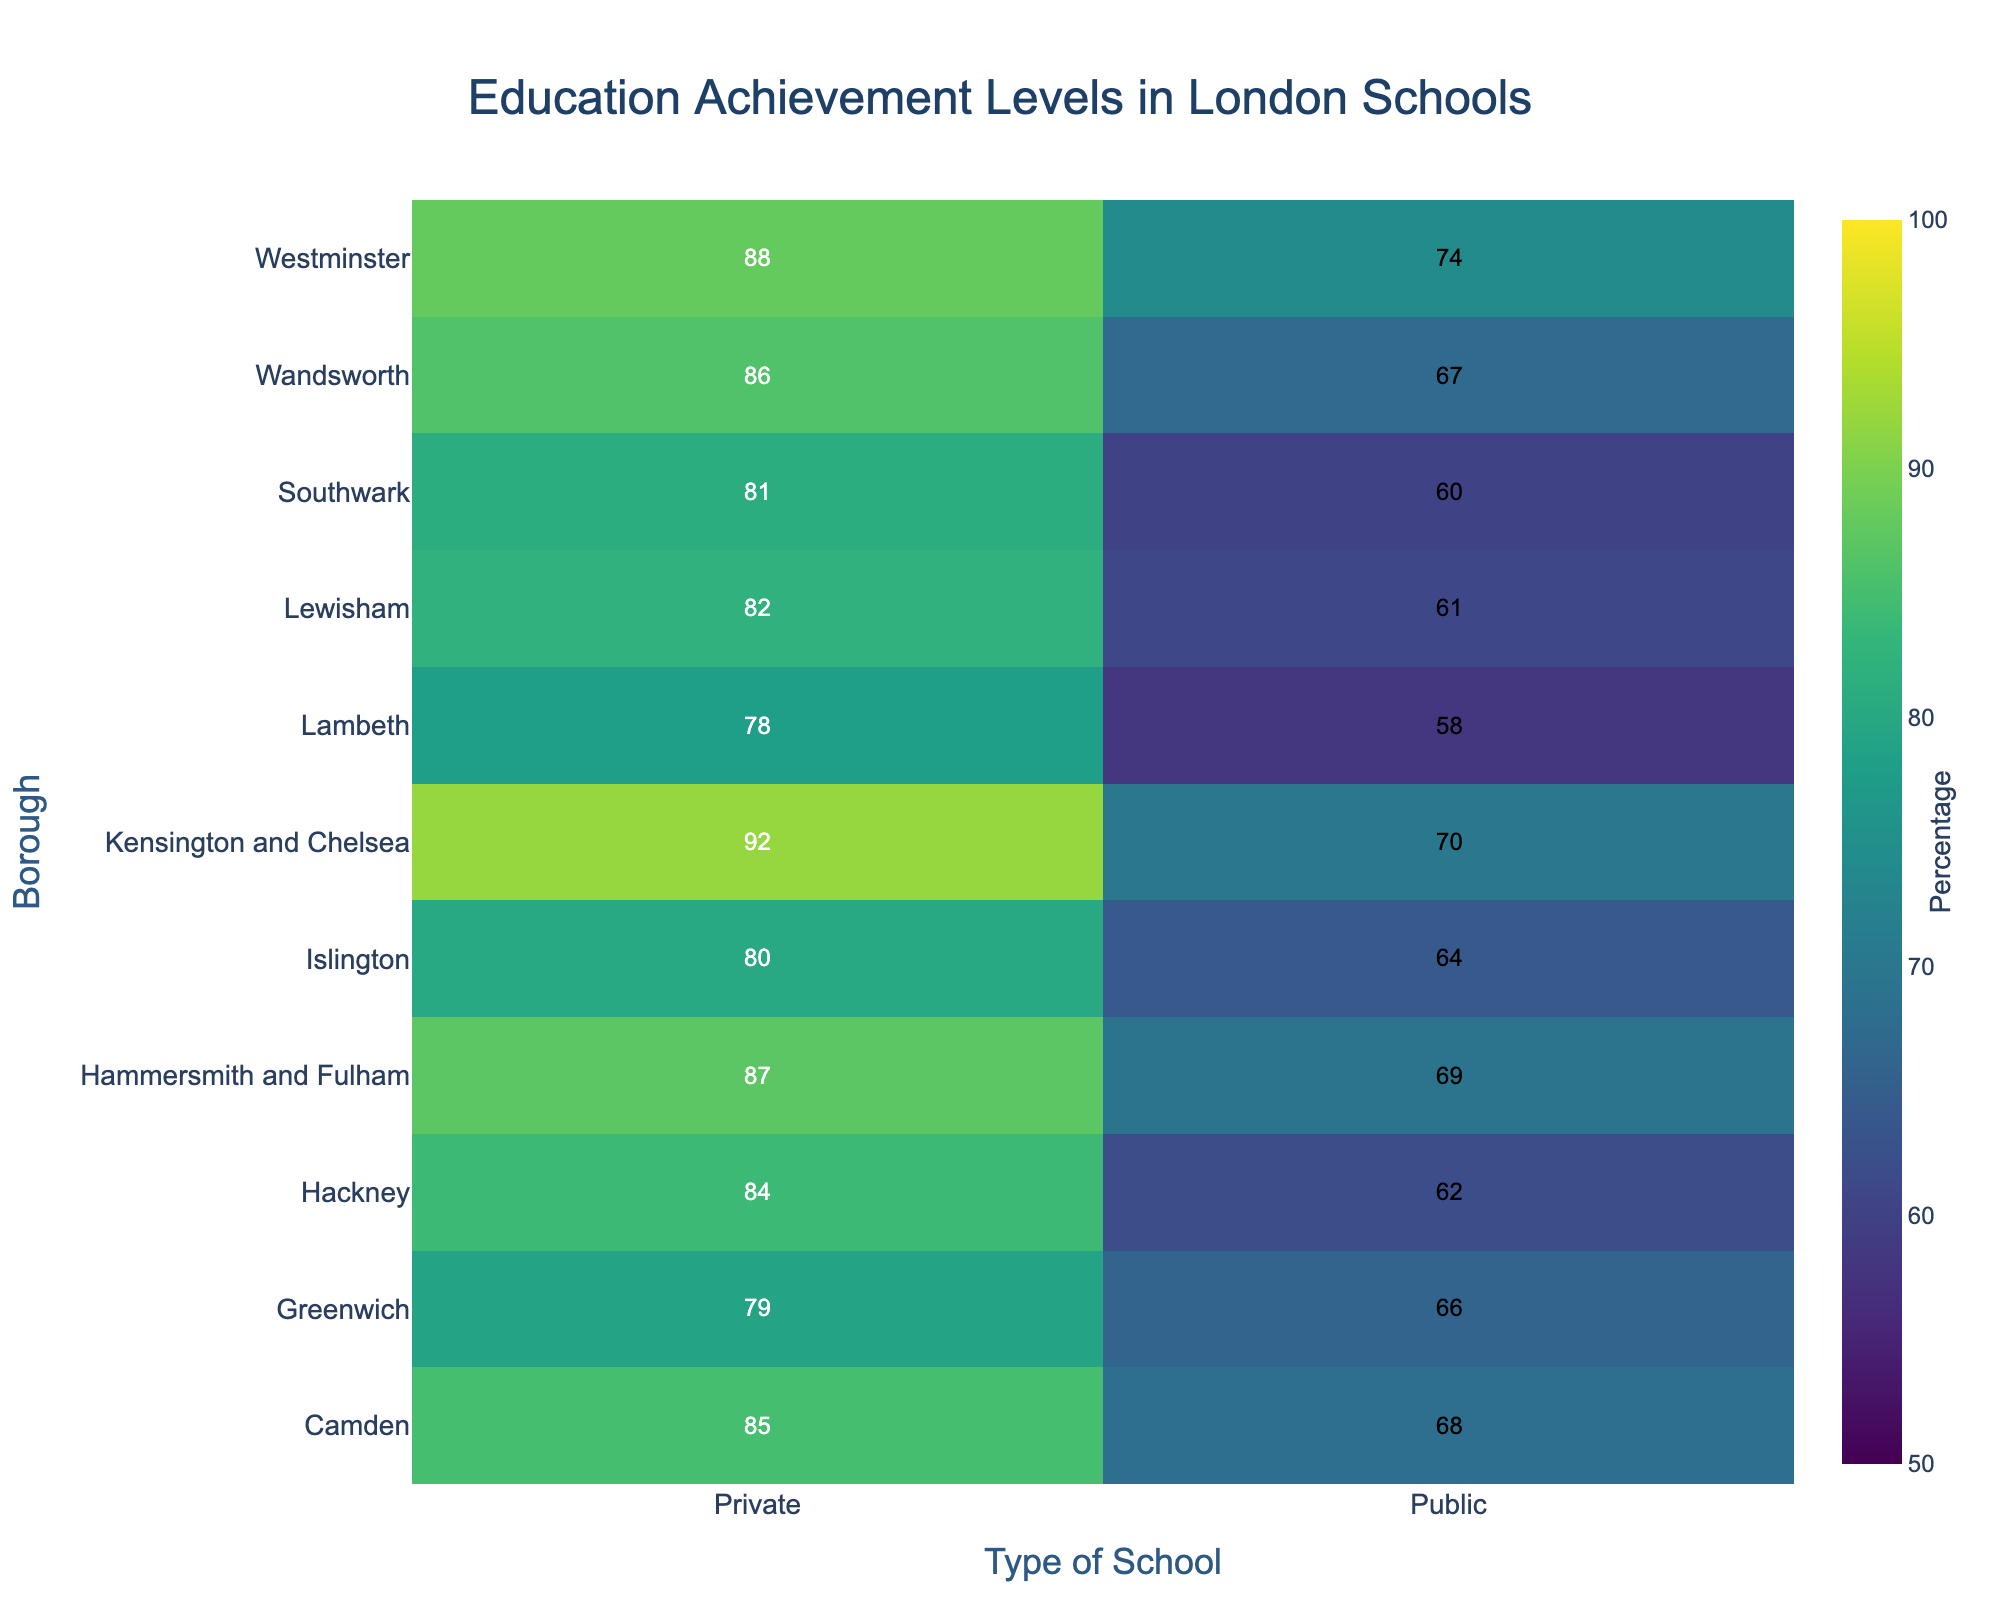What's the title of the heatmap? The title of the heatmap is usually found at the top and describes the content of the figure.
Answer: Education Achievement Levels in London Schools Which borough has the highest percentage of students achieving A*-C in private schools? Look for the highest value in the column under "Private" and identify the corresponding borough on the Y-axis.
Answer: Kensington and Chelsea Which type of school and borough combination has the lowest percentage of students achieving A*-C? Find the lowest value across the entire heatmap and check the Y-axis and X-axis for the corresponding borough and type of school.
Answer: Lambeth Public What’s the difference in achievement between Public and Private schools in Camden? Subtract the value in the "Public" column from the value in the "Private" column for the borough Camden.
Answer: 17 Which type of school generally has higher percentages of students achieving A*-C across all boroughs? Compare the color intensity and values in the "Public" and "Private" columns across all boroughs.
Answer: Private What is the average achievement percentage across Public schools in all boroughs? Add the values in the "Public" column and divide by the number of boroughs (10).
Answer: 65.9 Which borough shows the smallest difference in achievement between Public and Private schools? Calculate the absolute differences between "Public" and "Private" values for each borough and find the smallest one.
Answer: Greenwich How many boroughs have over 80% of students achieving A*-C in Private schools? Count the number of values in the "Private" column that are greater than 80%.
Answer: 8 Which borough and type of school combination is closest to the overall average achievement percentage for London? Calculate the average percentage for all values, then find the combination whose value is closest to this average.
Answer: Greenwich Public (66, overall average is approximately 74.3) What color represents the highest percentage of students achieving A*-C? Look for the color corresponding to the highest value on the heatmap color scale.
Answer: Bright yellow 